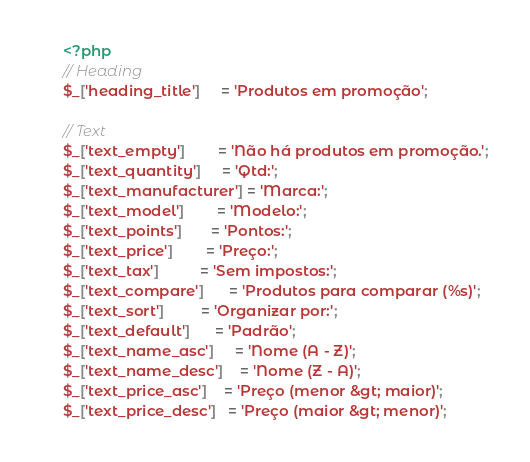<code> <loc_0><loc_0><loc_500><loc_500><_PHP_><?php
// Heading
$_['heading_title']     = 'Produtos em promoção';

// Text
$_['text_empty']        = 'Não há produtos em promoção.';
$_['text_quantity']     = 'Qtd:';
$_['text_manufacturer'] = 'Marca:';
$_['text_model']        = 'Modelo:';
$_['text_points']       = 'Pontos:';
$_['text_price']        = 'Preço:';
$_['text_tax']          = 'Sem impostos:';
$_['text_compare']      = 'Produtos para comparar (%s)';
$_['text_sort']         = 'Organizar por:';
$_['text_default']      = 'Padrão';
$_['text_name_asc']     = 'Nome (A - Z)';
$_['text_name_desc']    = 'Nome (Z - A)';
$_['text_price_asc']    = 'Preço (menor &gt; maior)';
$_['text_price_desc']   = 'Preço (maior &gt; menor)';</code> 